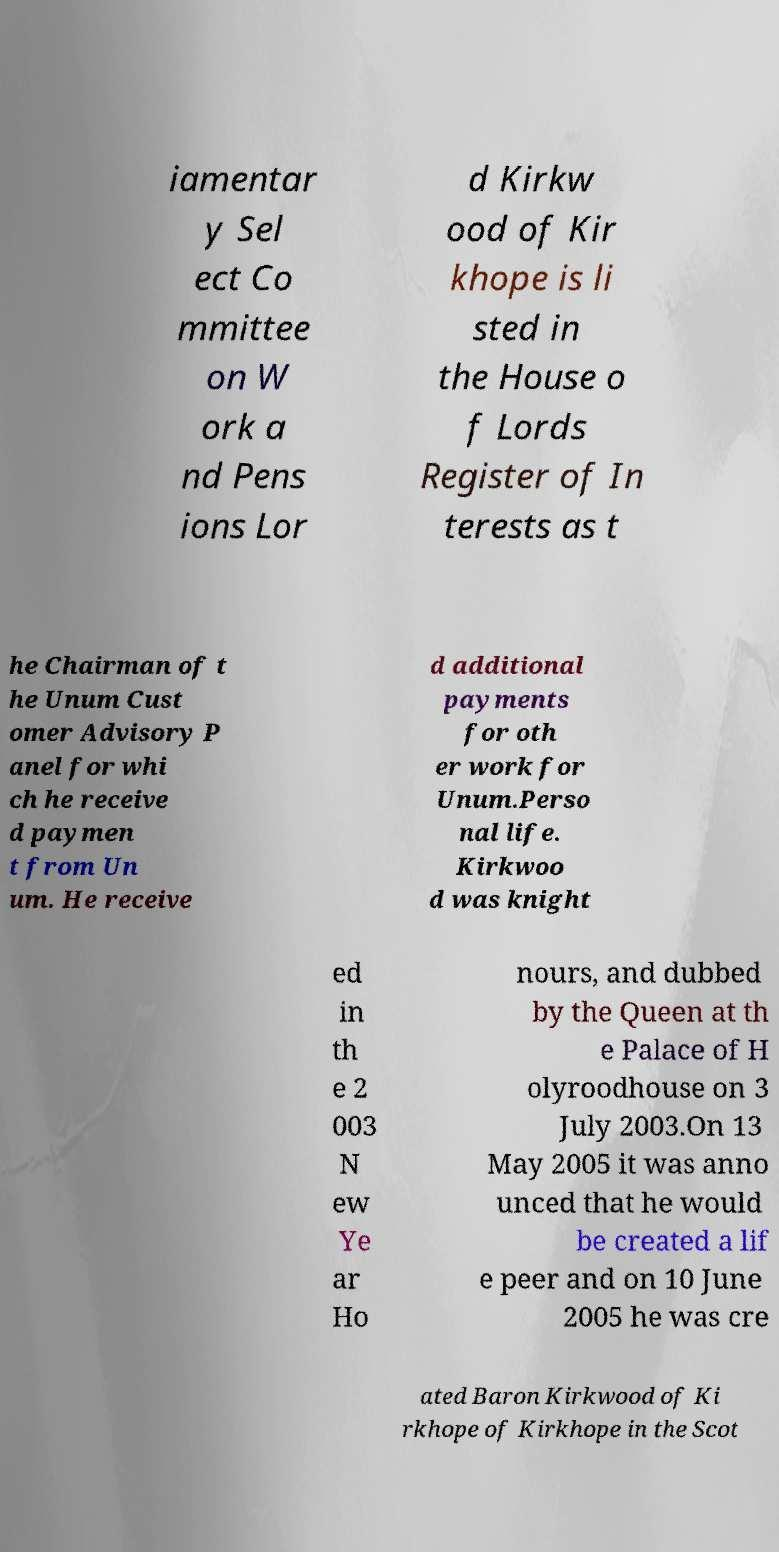Could you extract and type out the text from this image? iamentar y Sel ect Co mmittee on W ork a nd Pens ions Lor d Kirkw ood of Kir khope is li sted in the House o f Lords Register of In terests as t he Chairman of t he Unum Cust omer Advisory P anel for whi ch he receive d paymen t from Un um. He receive d additional payments for oth er work for Unum.Perso nal life. Kirkwoo d was knight ed in th e 2 003 N ew Ye ar Ho nours, and dubbed by the Queen at th e Palace of H olyroodhouse on 3 July 2003.On 13 May 2005 it was anno unced that he would be created a lif e peer and on 10 June 2005 he was cre ated Baron Kirkwood of Ki rkhope of Kirkhope in the Scot 